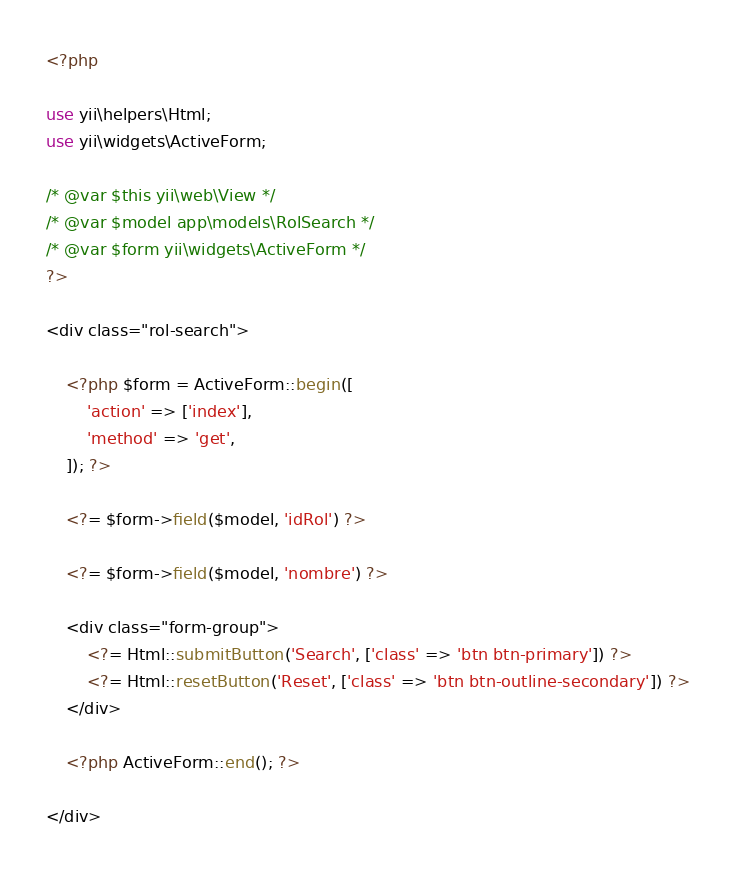<code> <loc_0><loc_0><loc_500><loc_500><_PHP_><?php

use yii\helpers\Html;
use yii\widgets\ActiveForm;

/* @var $this yii\web\View */
/* @var $model app\models\RolSearch */
/* @var $form yii\widgets\ActiveForm */
?>

<div class="rol-search">

    <?php $form = ActiveForm::begin([
        'action' => ['index'],
        'method' => 'get',
    ]); ?>

    <?= $form->field($model, 'idRol') ?>

    <?= $form->field($model, 'nombre') ?>

    <div class="form-group">
        <?= Html::submitButton('Search', ['class' => 'btn btn-primary']) ?>
        <?= Html::resetButton('Reset', ['class' => 'btn btn-outline-secondary']) ?>
    </div>

    <?php ActiveForm::end(); ?>

</div>
</code> 